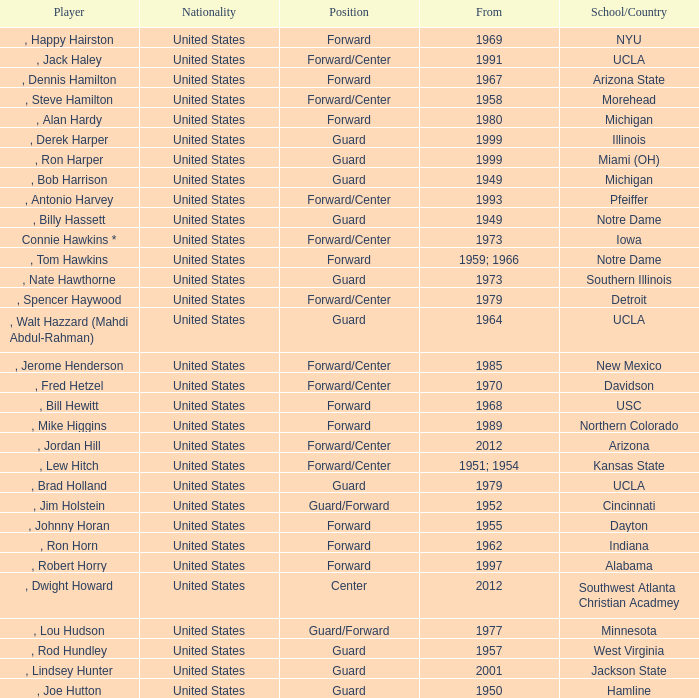What position was for Arizona State? Forward. 